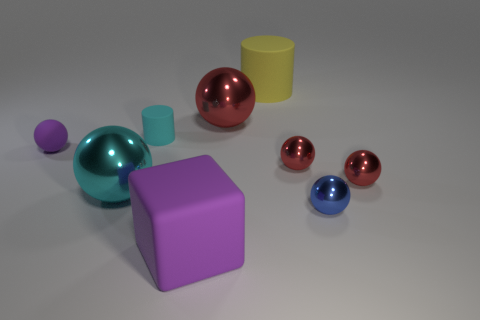What is the color of the matte cube?
Offer a very short reply. Purple. There is a blue shiny object; what shape is it?
Offer a very short reply. Sphere. Is the cylinder to the left of the large yellow cylinder made of the same material as the cube?
Your response must be concise. Yes. How big is the purple thing that is to the left of the large matte thing that is in front of the purple matte sphere?
Ensure brevity in your answer.  Small. There is a thing that is both left of the blue metal ball and in front of the cyan ball; what is its color?
Your answer should be compact. Purple. There is a cylinder that is the same size as the blue sphere; what is its material?
Ensure brevity in your answer.  Rubber. What number of other things are there of the same material as the cyan cylinder
Offer a very short reply. 3. Is the color of the ball that is in front of the cyan shiny sphere the same as the metal ball that is on the left side of the large rubber cube?
Your answer should be very brief. No. There is a purple object that is behind the purple thing to the right of the cyan metal ball; what is its shape?
Keep it short and to the point. Sphere. How many other things are the same color as the rubber ball?
Provide a succinct answer. 1. 